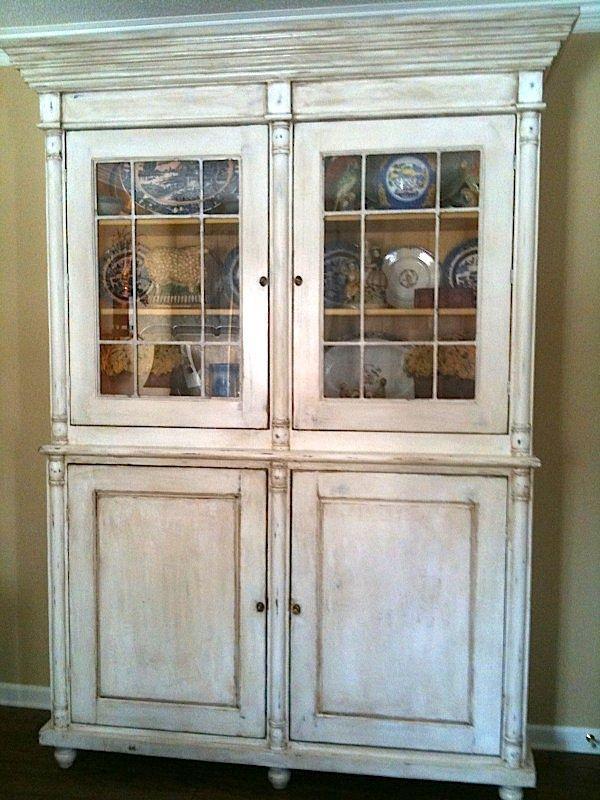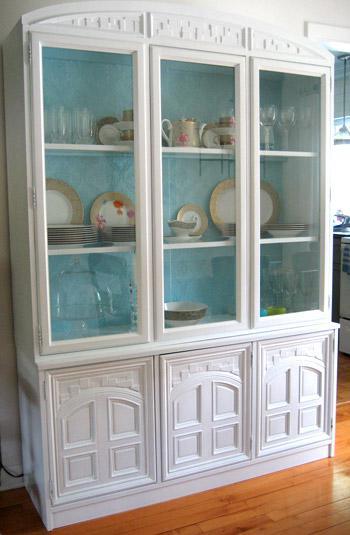The first image is the image on the left, the second image is the image on the right. Considering the images on both sides, is "A wreath is hanging on a white china cabinet." valid? Answer yes or no. No. The first image is the image on the left, the second image is the image on the right. Evaluate the accuracy of this statement regarding the images: "The right image has a cabinet with a green wreath hanging on it.". Is it true? Answer yes or no. No. 